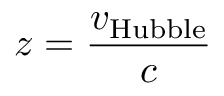<formula> <loc_0><loc_0><loc_500><loc_500>z = { \frac { v _ { H u b b l e } } { c } }</formula> 